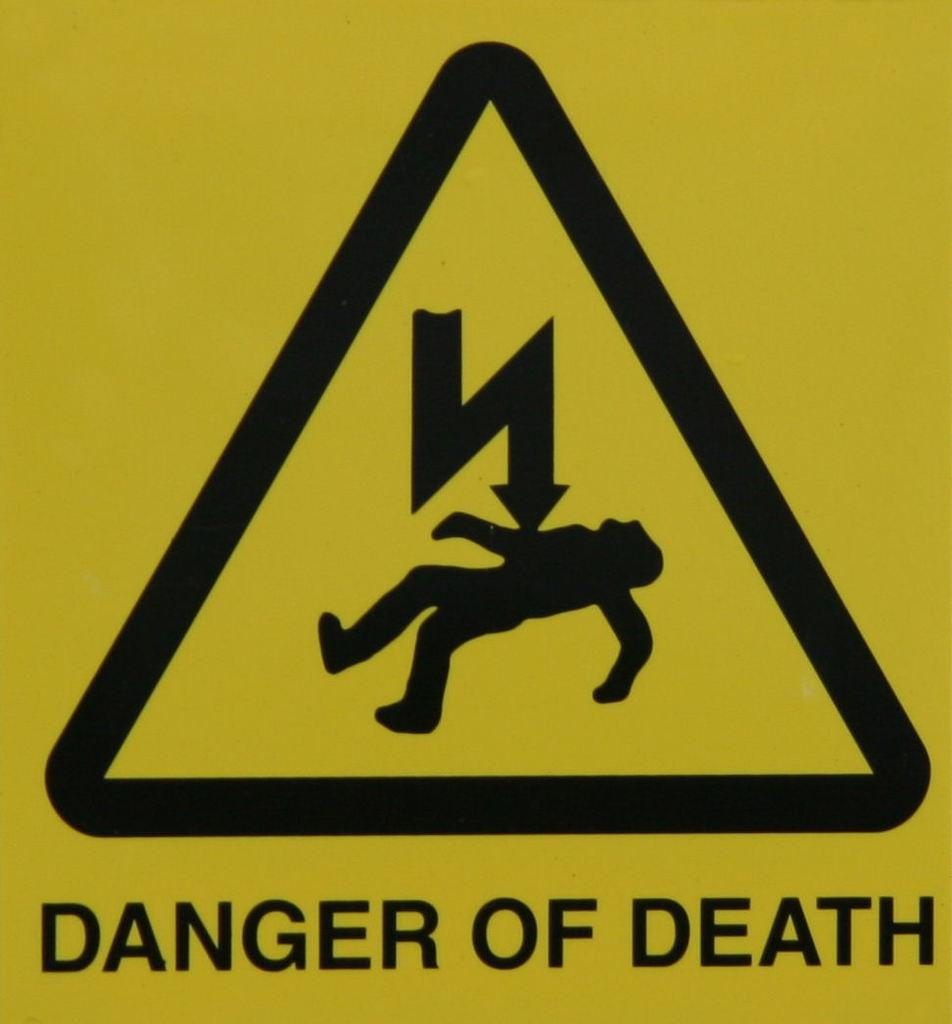What is present on the board in the image? There is a logo and text on the board. Can you describe the logo on the board? Unfortunately, the specific details of the logo cannot be determined from the image alone. What information is provided by the text on the board? The content of the text on the board cannot be determined from the image alone. What type of cemetery can be seen in the background of the image? There is no cemetery present in the image. What tools might a carpenter be using in the image? There is no carpenter or tools present in the image. How many halls are visible in the image? There is no hall present in the image. 